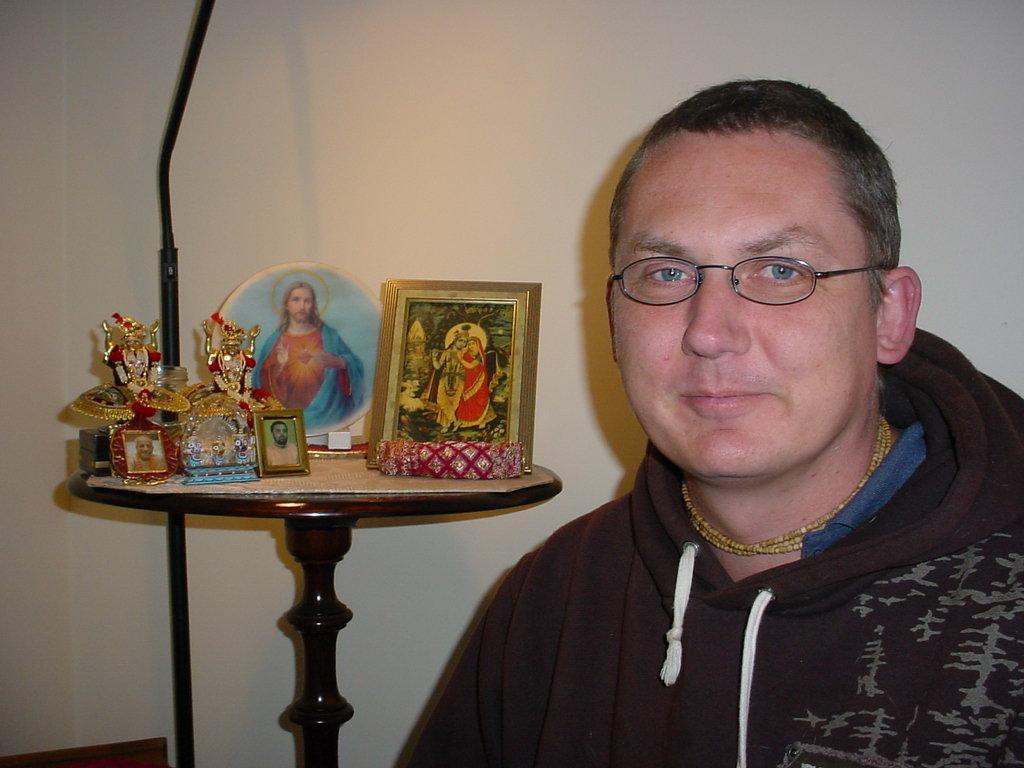How would you summarize this image in a sentence or two? In this image we can see a man wearing glasses and smiling. In the background we can see some idols and frames on the table. We can also see the plain wall. 